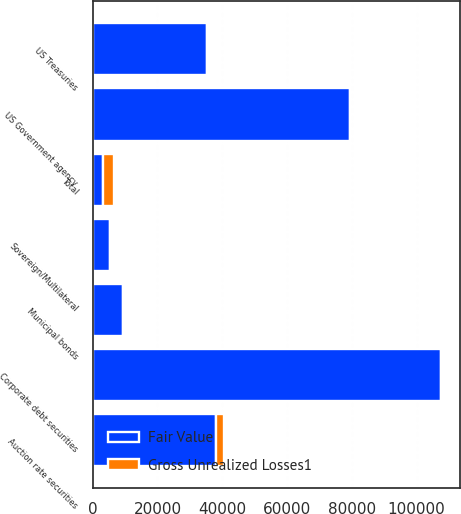Convert chart. <chart><loc_0><loc_0><loc_500><loc_500><stacked_bar_chart><ecel><fcel>US Treasuries<fcel>US Government agency<fcel>Municipal bonds<fcel>Corporate debt securities<fcel>Sovereign/Multilateral<fcel>Auction rate securities<fcel>Total<nl><fcel>Fair Value<fcel>35224<fcel>79345<fcel>9455<fcel>107597<fcel>5188<fcel>38168<fcel>3300<nl><fcel>Gross Unrealized Losses1<fcel>7<fcel>155<fcel>68<fcel>557<fcel>31<fcel>2482<fcel>3300<nl></chart> 